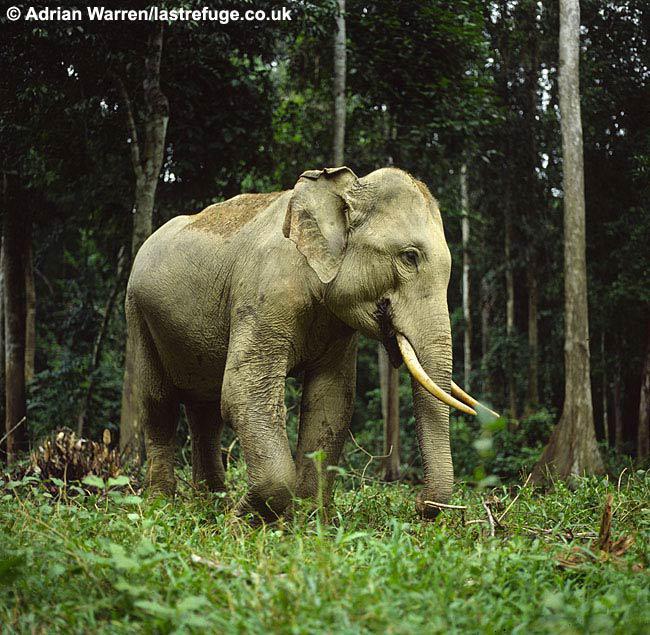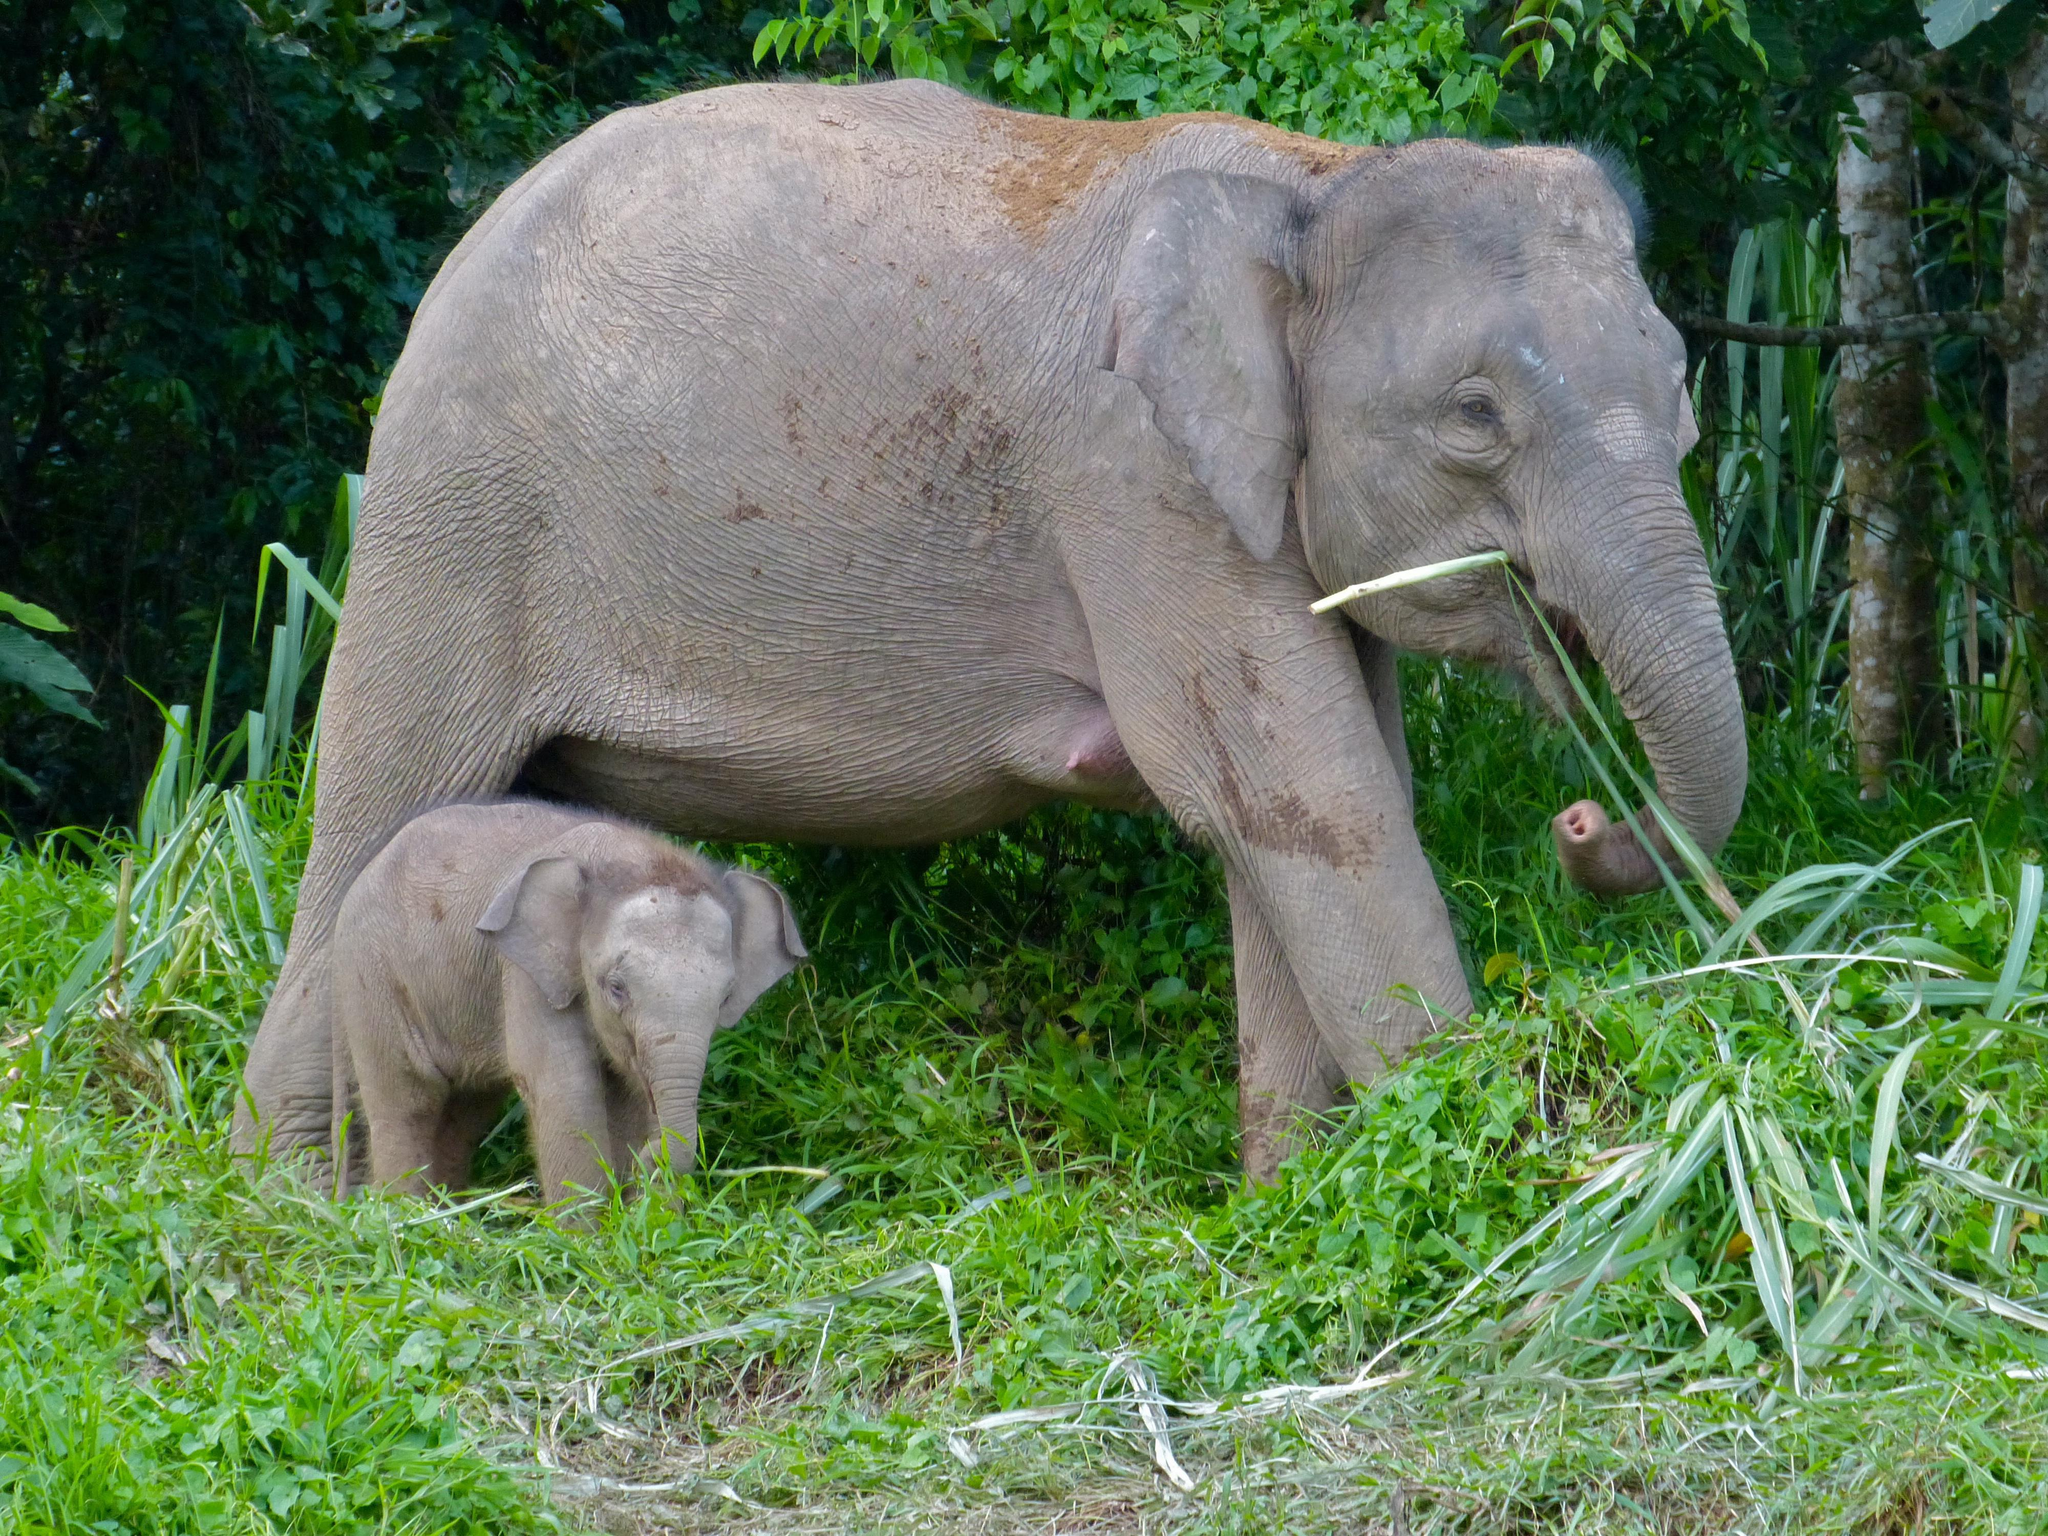The first image is the image on the left, the second image is the image on the right. Considering the images on both sides, is "One image shows an elephant with large tusks." valid? Answer yes or no. Yes. The first image is the image on the left, the second image is the image on the right. Evaluate the accuracy of this statement regarding the images: "There is exactly one elephant in the image on the right.". Is it true? Answer yes or no. No. The first image is the image on the left, the second image is the image on the right. Considering the images on both sides, is "Only one image shows a single elephant with tusks." valid? Answer yes or no. Yes. The first image is the image on the left, the second image is the image on the right. For the images shown, is this caption "Three elephants in total." true? Answer yes or no. Yes. 